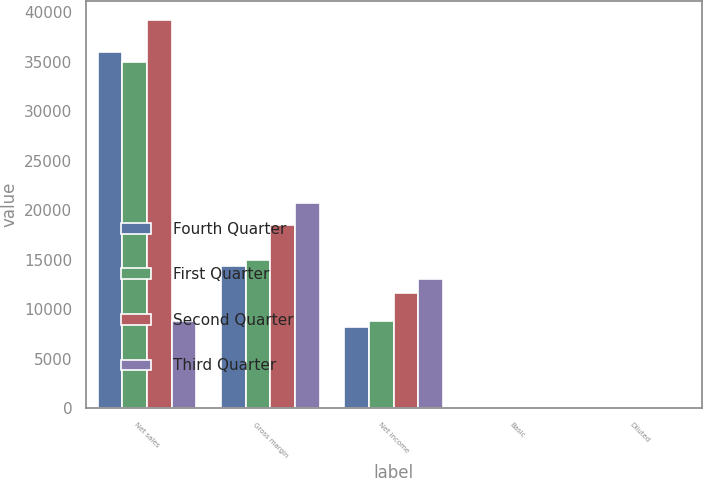<chart> <loc_0><loc_0><loc_500><loc_500><stacked_bar_chart><ecel><fcel>Net sales<fcel>Gross margin<fcel>Net income<fcel>Basic<fcel>Diluted<nl><fcel>Fourth Quarter<fcel>35966<fcel>14401<fcel>8223<fcel>8.76<fcel>8.67<nl><fcel>First Quarter<fcel>35023<fcel>14994<fcel>8824<fcel>9.42<fcel>9.32<nl><fcel>Second Quarter<fcel>39186<fcel>18564<fcel>11622<fcel>12.45<fcel>12.3<nl><fcel>Third Quarter<fcel>8824<fcel>20703<fcel>13064<fcel>14.03<fcel>13.87<nl></chart> 